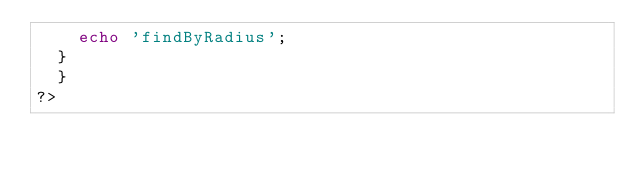Convert code to text. <code><loc_0><loc_0><loc_500><loc_500><_PHP_>	  echo 'findByRadius';
	}
  }
?></code> 